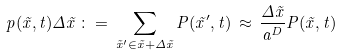Convert formula to latex. <formula><loc_0><loc_0><loc_500><loc_500>p ( \vec { x } , t ) \Delta \vec { x } \, \colon = \, \sum _ { \vec { x } ^ { \prime } \in \vec { x } + \Delta \vec { x } } P ( \vec { x } ^ { \prime } , t ) \, \approx \, \frac { \Delta \vec { x } } { a ^ { D } } P ( \vec { x } , t )</formula> 